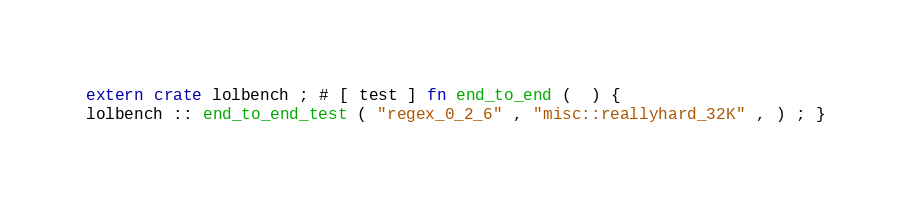<code> <loc_0><loc_0><loc_500><loc_500><_Rust_>extern crate lolbench ; # [ test ] fn end_to_end (  ) {
lolbench :: end_to_end_test ( "regex_0_2_6" , "misc::reallyhard_32K" , ) ; }</code> 